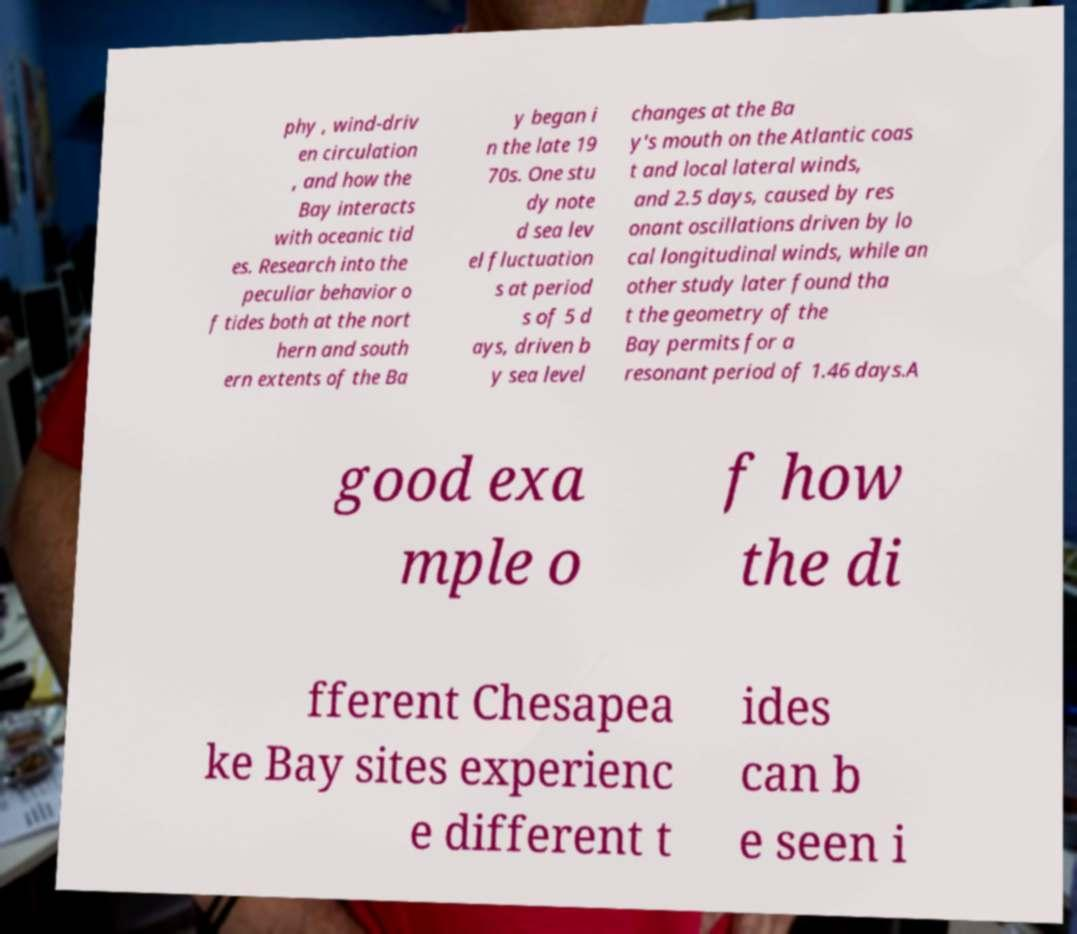Can you accurately transcribe the text from the provided image for me? phy , wind-driv en circulation , and how the Bay interacts with oceanic tid es. Research into the peculiar behavior o f tides both at the nort hern and south ern extents of the Ba y began i n the late 19 70s. One stu dy note d sea lev el fluctuation s at period s of 5 d ays, driven b y sea level changes at the Ba y's mouth on the Atlantic coas t and local lateral winds, and 2.5 days, caused by res onant oscillations driven by lo cal longitudinal winds, while an other study later found tha t the geometry of the Bay permits for a resonant period of 1.46 days.A good exa mple o f how the di fferent Chesapea ke Bay sites experienc e different t ides can b e seen i 